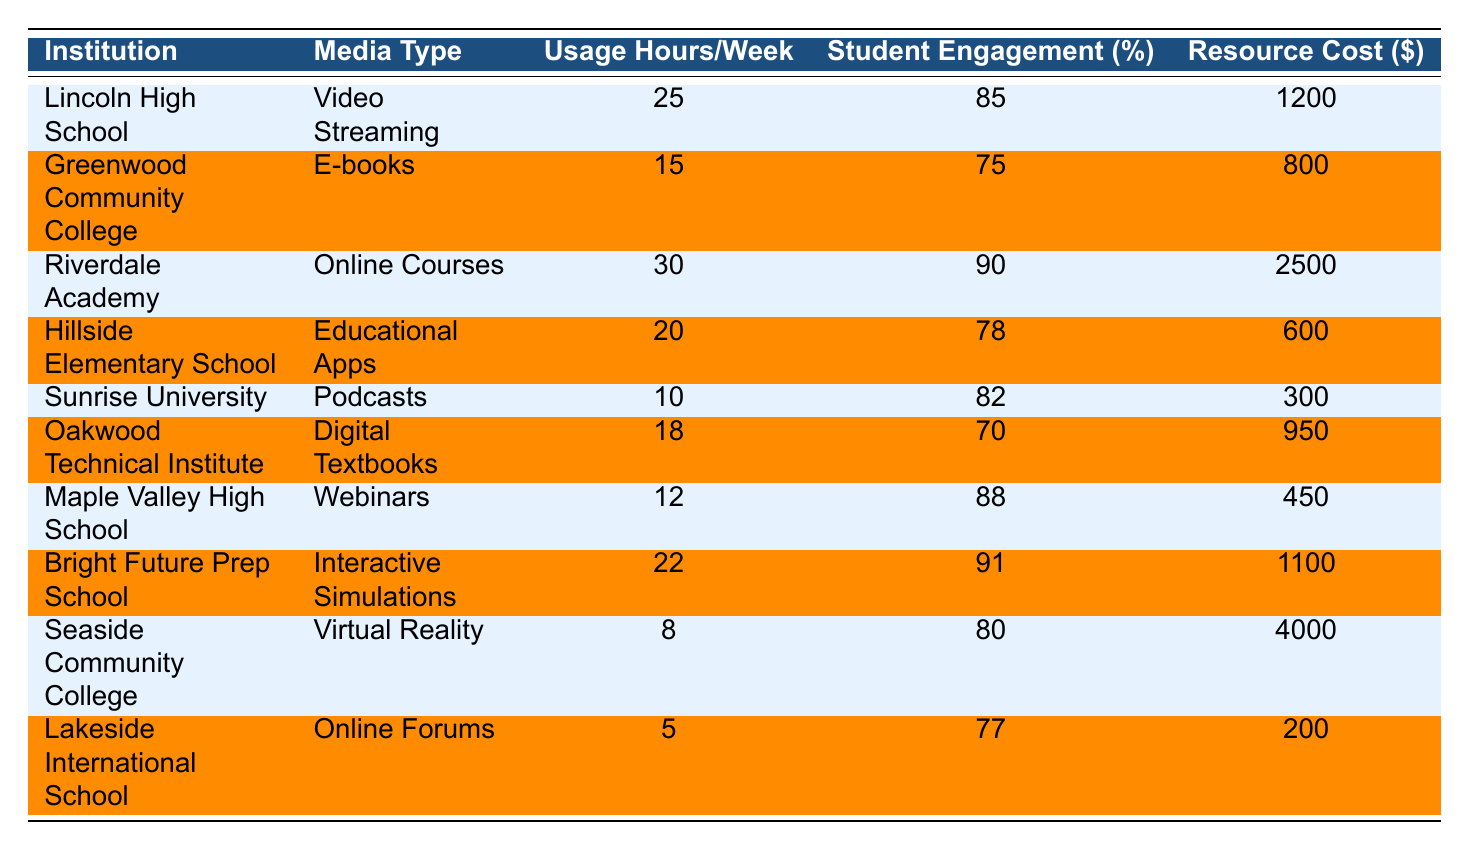What media type had the highest student engagement rate? By examining the "Student Engagement Rate (%)" column, I identify the highest value from each row. The maximum engagement rate is 91%, which corresponds to "Interactive Simulations" used at "Bright Future Prep School".
Answer: Interactive Simulations What is the total cost of resources for Lincoln High School and Riverdale Academy combined? I find the resource costs for both institutions: Lincoln High School has a cost of $1200 and Riverdale Academy has a cost of $2500. Adding these gives $1200 + $2500 = $3700.
Answer: $3700 How many hours per week does Lakeside International School use media resources? The table shows that "Lakeside International School" uses media resources for 5 hours per week as specified in the "Usage Hours per Week" column.
Answer: 5 Is the engagement rate for Online Courses at Riverdale Academy higher than that for Digital Textbooks at Oakwood Technical Institute? The engagement rate for Online Courses at Riverdale Academy is 90% and for Digital Textbooks at Oakwood Technical Institute is 70%. Since 90% is greater than 70%, the statement is true.
Answer: Yes What percentage of student engagement is reported for podcasts, and how does it compare to e-books? The engagement rate for Podcasts at Sunrise University is 82%, and for E-books at Greenwood Community College, it is 75%. Comparing these rates shows that 82% is higher than 75%.
Answer: 82%, higher than e-books Which institution utilizes media resources for the least number of hours per week, and what is that usage? From the "Usage Hours per Week" column, I find the minimum value, which is 5 hours associated with "Lakeside International School".
Answer: Lakeside International School, 5 hours What is the average usage hours per week across all institutions? I sum the usage hours: 25 + 15 + 30 + 20 + 10 + 18 + 12 + 22 + 8 + 5 =  25 + 15 + 30 + 20 + 10 + 18 + 12 + 22 + 8 + 5 =  25 + 15 = 40, 40 + 30 = 70, 70 + 20 = 90, 90 + 10 = 100, 100 + 18 = 118, 118 + 12 = 130, 130 + 22 = 152, 152 + 8 = 160, 160 + 5 = 165. Then I divide by the number of institutions (10), which gives an average of 165 / 10 = 16.5.
Answer: 16.5 How does the student engagement rate of Seaside Community College compare to that of Bright Future Prep School? The engagement rate for Seaside Community College is 80% and for Bright Future Prep School is 91%. Since 80% is less than 91%, Seaside Community College has a lower engagement rate.
Answer: Lower What is the difference in usage hours per week between the institution with the highest and lowest engagement rates? The institution with the highest engagement rate is Bright Future Prep School with 22 usage hours, and Lakeside International School has the lowest with 5 hours. The difference is 22 - 5 = 17 hours.
Answer: 17 hours 